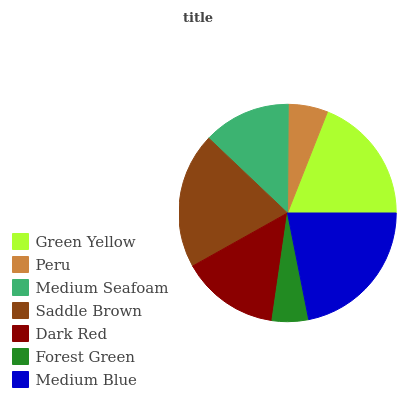Is Forest Green the minimum?
Answer yes or no. Yes. Is Medium Blue the maximum?
Answer yes or no. Yes. Is Peru the minimum?
Answer yes or no. No. Is Peru the maximum?
Answer yes or no. No. Is Green Yellow greater than Peru?
Answer yes or no. Yes. Is Peru less than Green Yellow?
Answer yes or no. Yes. Is Peru greater than Green Yellow?
Answer yes or no. No. Is Green Yellow less than Peru?
Answer yes or no. No. Is Dark Red the high median?
Answer yes or no. Yes. Is Dark Red the low median?
Answer yes or no. Yes. Is Peru the high median?
Answer yes or no. No. Is Medium Blue the low median?
Answer yes or no. No. 